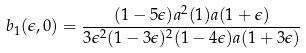Convert formula to latex. <formula><loc_0><loc_0><loc_500><loc_500>b _ { 1 } ( \epsilon , 0 ) = \frac { ( 1 - 5 \epsilon ) a ^ { 2 } ( 1 ) a ( 1 + \epsilon ) } { 3 \epsilon ^ { 2 } ( 1 - 3 \epsilon ) ^ { 2 } ( 1 - 4 \epsilon ) a ( 1 + 3 \epsilon ) }</formula> 